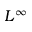<formula> <loc_0><loc_0><loc_500><loc_500>L ^ { \infty }</formula> 